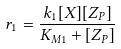<formula> <loc_0><loc_0><loc_500><loc_500>r _ { 1 } = \frac { k _ { 1 } [ X ] [ Z _ { P } ] } { K _ { M 1 } + [ Z _ { P } ] }</formula> 